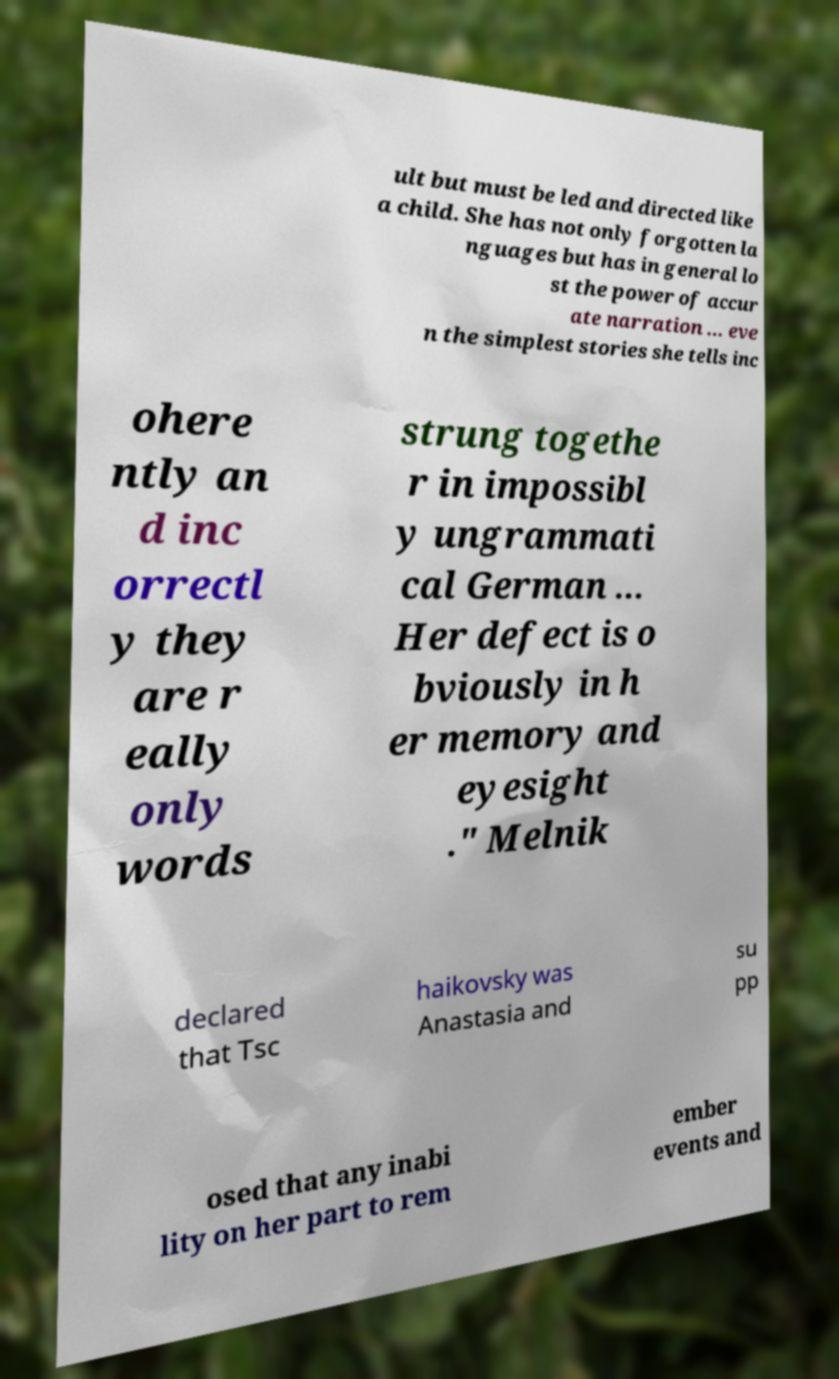Please identify and transcribe the text found in this image. ult but must be led and directed like a child. She has not only forgotten la nguages but has in general lo st the power of accur ate narration ... eve n the simplest stories she tells inc ohere ntly an d inc orrectl y they are r eally only words strung togethe r in impossibl y ungrammati cal German ... Her defect is o bviously in h er memory and eyesight ." Melnik declared that Tsc haikovsky was Anastasia and su pp osed that any inabi lity on her part to rem ember events and 